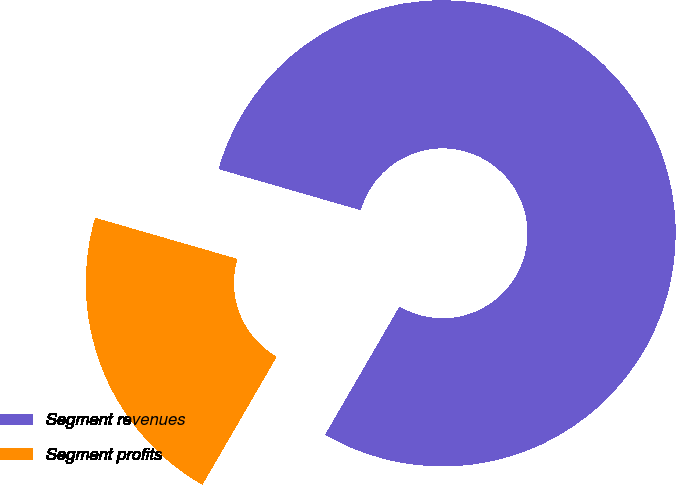Convert chart. <chart><loc_0><loc_0><loc_500><loc_500><pie_chart><fcel>Segment revenues<fcel>Segment profits<nl><fcel>78.89%<fcel>21.11%<nl></chart> 